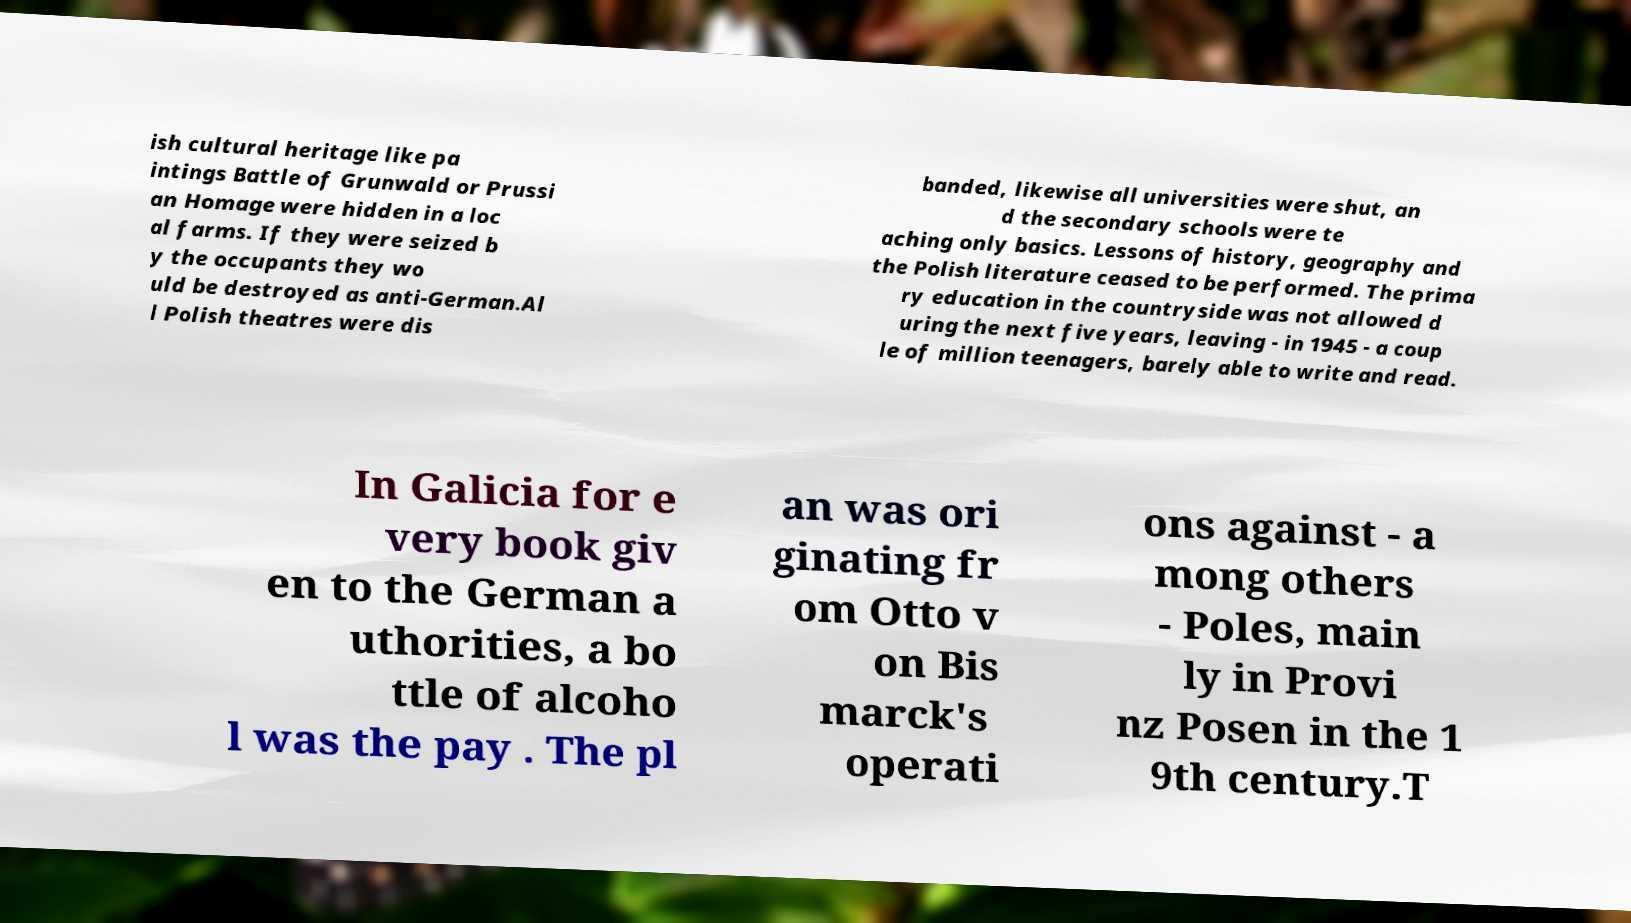For documentation purposes, I need the text within this image transcribed. Could you provide that? ish cultural heritage like pa intings Battle of Grunwald or Prussi an Homage were hidden in a loc al farms. If they were seized b y the occupants they wo uld be destroyed as anti-German.Al l Polish theatres were dis banded, likewise all universities were shut, an d the secondary schools were te aching only basics. Lessons of history, geography and the Polish literature ceased to be performed. The prima ry education in the countryside was not allowed d uring the next five years, leaving - in 1945 - a coup le of million teenagers, barely able to write and read. In Galicia for e very book giv en to the German a uthorities, a bo ttle of alcoho l was the pay . The pl an was ori ginating fr om Otto v on Bis marck's operati ons against - a mong others - Poles, main ly in Provi nz Posen in the 1 9th century.T 